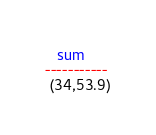<code> <loc_0><loc_0><loc_500><loc_500><_SQL_>
   sum
-----------
 (34,53.9)
</code> 